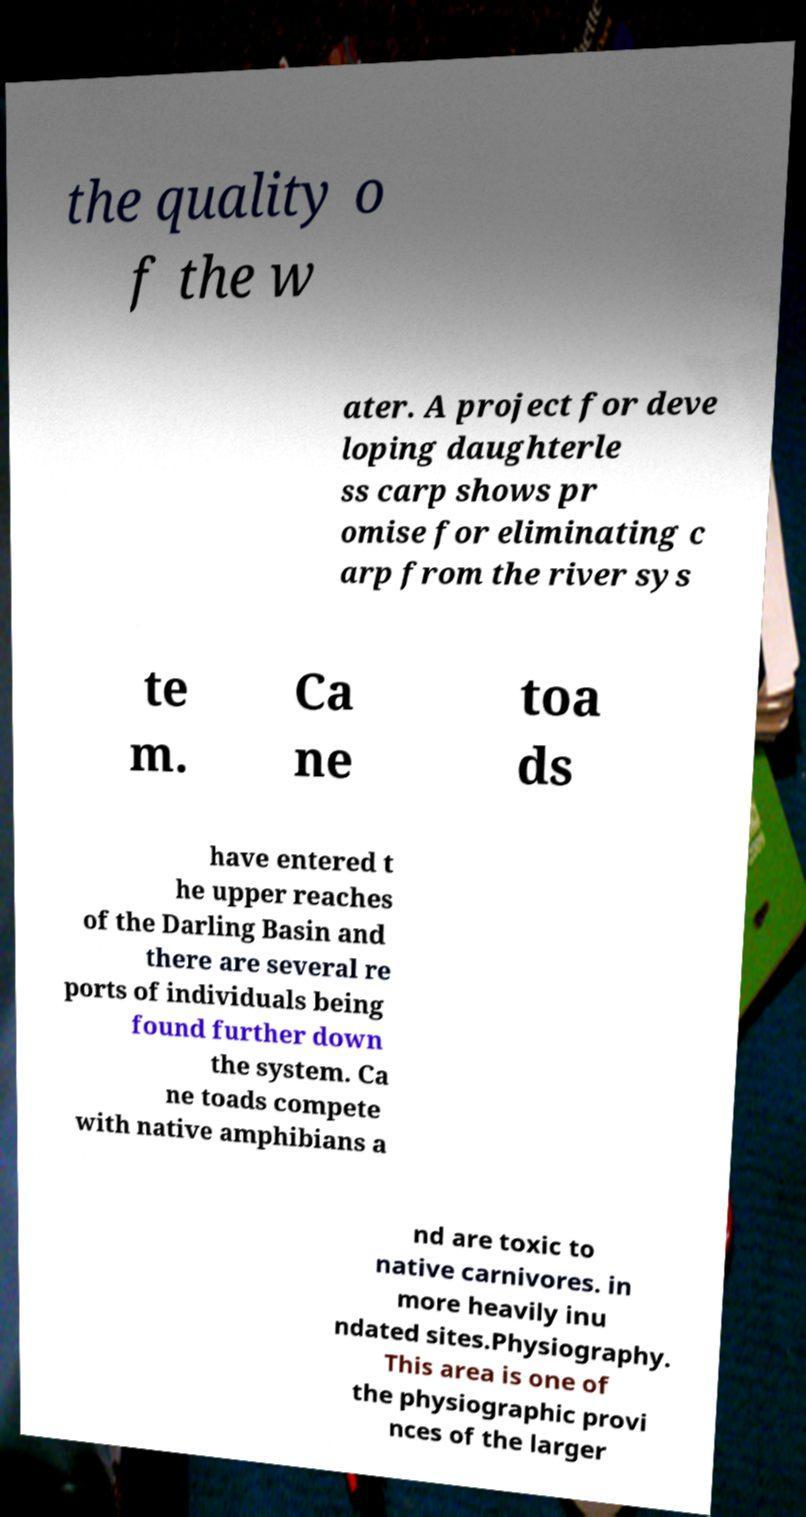What messages or text are displayed in this image? I need them in a readable, typed format. the quality o f the w ater. A project for deve loping daughterle ss carp shows pr omise for eliminating c arp from the river sys te m. Ca ne toa ds have entered t he upper reaches of the Darling Basin and there are several re ports of individuals being found further down the system. Ca ne toads compete with native amphibians a nd are toxic to native carnivores. in more heavily inu ndated sites.Physiography. This area is one of the physiographic provi nces of the larger 